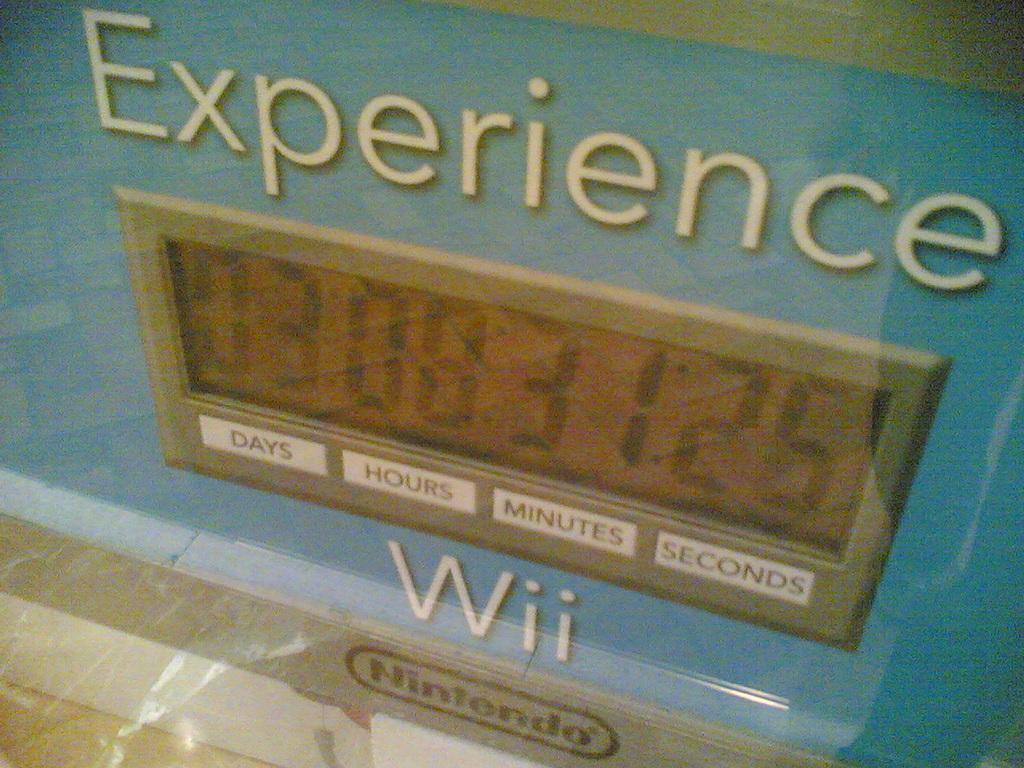What is this an experience of?
Your answer should be compact. Wii. How many seconds are left?
Provide a succinct answer. 25. 